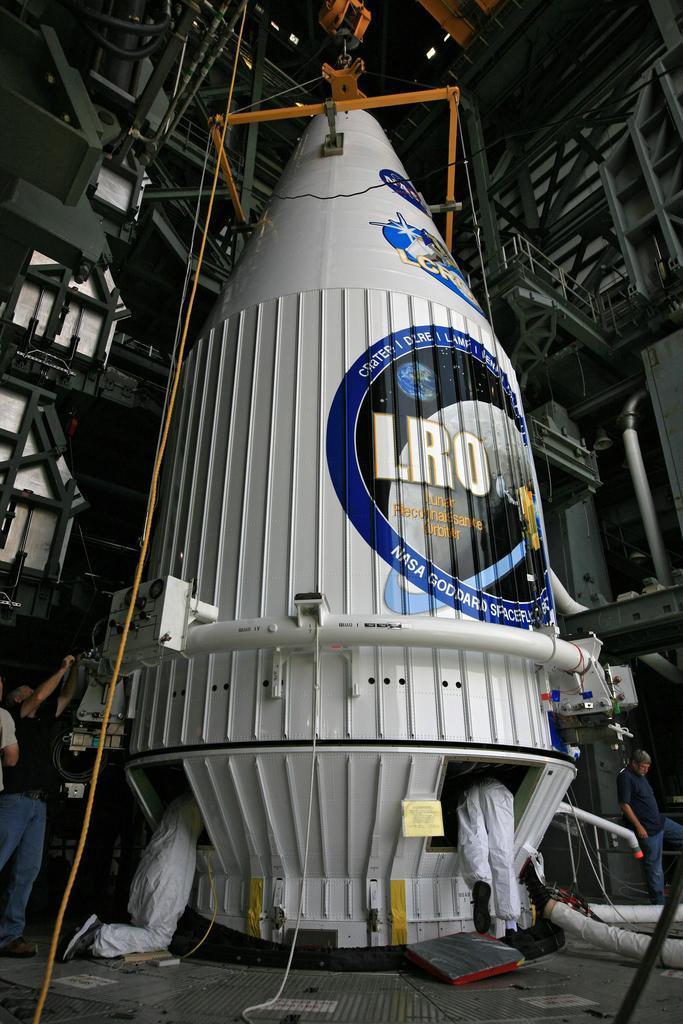How would you summarize this image in a sentence or two? In this image we can see a spaceship and people are working on it. 